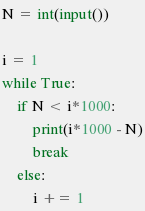Convert code to text. <code><loc_0><loc_0><loc_500><loc_500><_Python_>N = int(input())

i = 1
while True:
    if N < i*1000:
        print(i*1000 - N)
        break
    else:
        i += 1</code> 